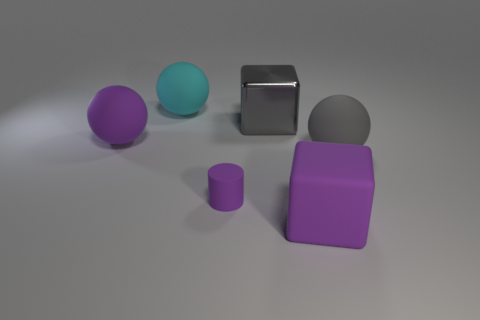Subtract all purple spheres. How many spheres are left? 2 Add 1 purple matte cylinders. How many objects exist? 7 Subtract all blocks. How many objects are left? 4 Subtract 2 balls. How many balls are left? 1 Subtract all gray cylinders. How many blue blocks are left? 0 Subtract all purple cylinders. Subtract all gray metallic cubes. How many objects are left? 4 Add 5 large cubes. How many large cubes are left? 7 Add 6 metallic things. How many metallic things exist? 7 Subtract 0 green balls. How many objects are left? 6 Subtract all red balls. Subtract all cyan cylinders. How many balls are left? 3 